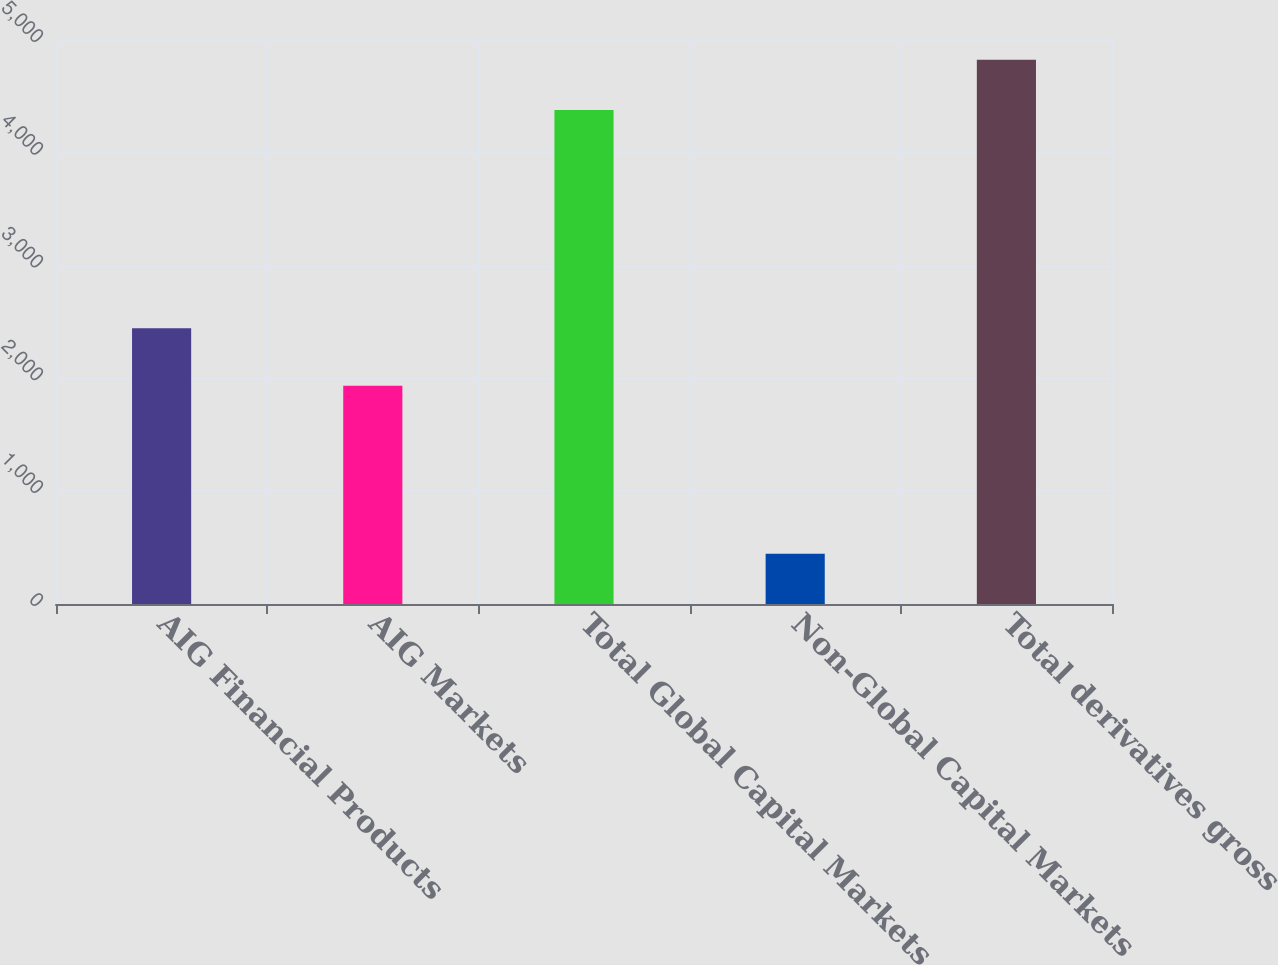Convert chart to OTSL. <chart><loc_0><loc_0><loc_500><loc_500><bar_chart><fcel>AIG Financial Products<fcel>AIG Markets<fcel>Total Global Capital Markets<fcel>Non-Global Capital Markets<fcel>Total derivatives gross<nl><fcel>2445<fcel>1935<fcel>4380<fcel>445<fcel>4825<nl></chart> 